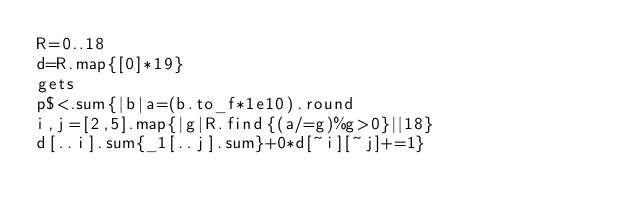Convert code to text. <code><loc_0><loc_0><loc_500><loc_500><_Ruby_>R=0..18
d=R.map{[0]*19}
gets
p$<.sum{|b|a=(b.to_f*1e10).round
i,j=[2,5].map{|g|R.find{(a/=g)%g>0}||18}
d[..i].sum{_1[..j].sum}+0*d[~i][~j]+=1}</code> 